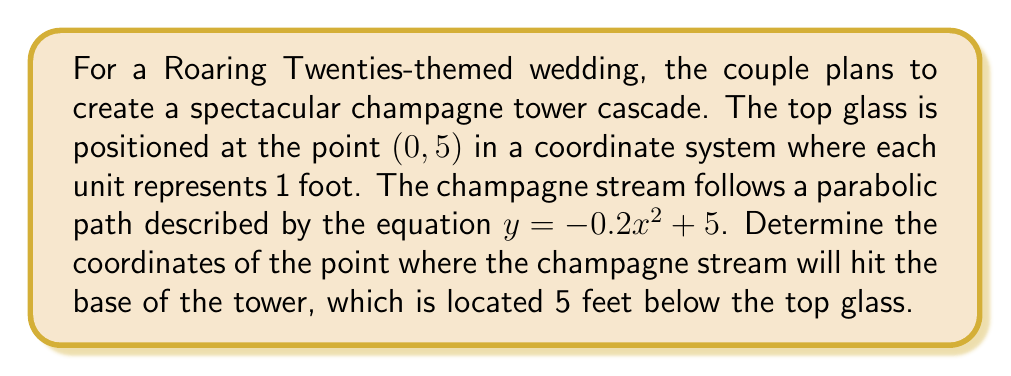Give your solution to this math problem. To solve this problem, we need to follow these steps:

1) The parabolic equation of the champagne stream is given as:
   $y = -0.2x^2 + 5$

2) We know that the base of the tower is 5 feet below the top glass. Since the top glass is at y = 5, the base is at y = 0.

3) To find where the stream hits the base, we need to solve the equation:
   $0 = -0.2x^2 + 5$

4) Rearranging the equation:
   $0.2x^2 = 5$
   $x^2 = 25$

5) Taking the square root of both sides:
   $x = \pm 5$

6) Since the champagne is flowing downward and to the right, we take the positive solution:
   $x = 5$

7) Therefore, the champagne stream will hit the base at the point (5, 0).

[asy]
unitsize(1cm);
defaultpen(fontsize(10pt));

// Draw axes
draw((-1,0)--(6,0), arrow=Arrow(TeXHead));
draw((0,-1)--(0,6), arrow=Arrow(TeXHead));

// Label axes
label("x", (6,0), E);
label("y", (0,6), N);

// Draw parabola
path p = graph(function(-0.2x^2+5), -5, 5);
draw(p, blue);

// Draw points
dot((0,5), red);
dot((5,0), red);

// Label points
label("(0, 5)", (0,5), NE);
label("(5, 0)", (5,0), SE);

// Label parabola
label("$y = -0.2x^2 + 5$", (3,3), E);
[/asy]
Answer: The champagne stream will hit the base of the tower at the point (5, 0). 